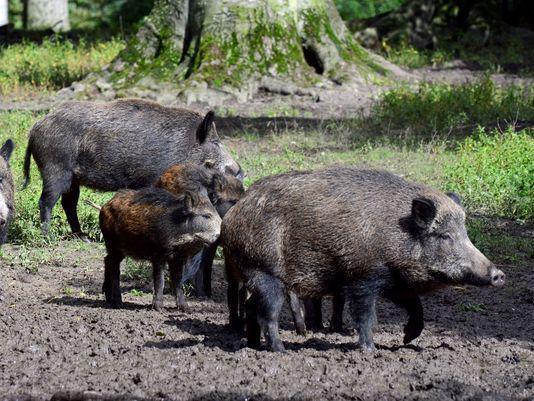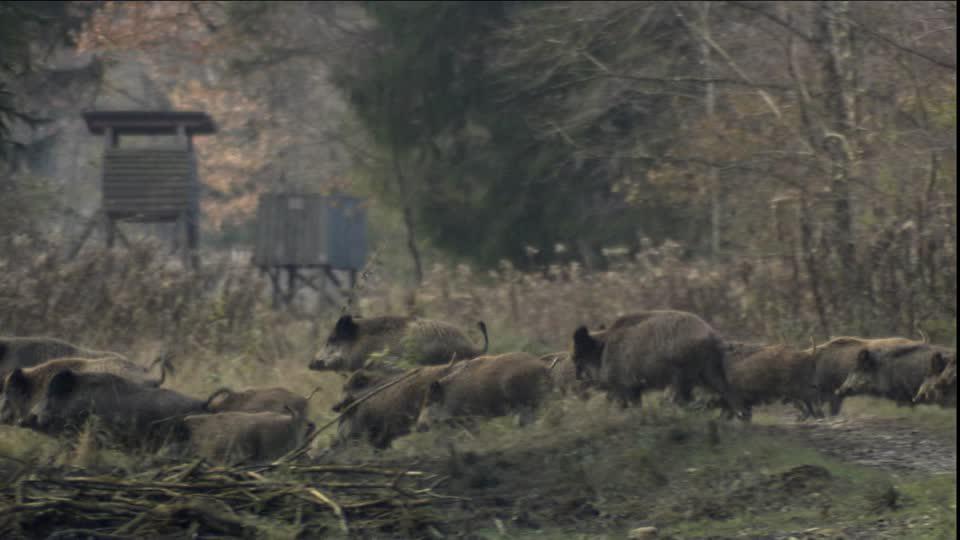The first image is the image on the left, the second image is the image on the right. Considering the images on both sides, is "An image contains one wild pig in the foreground with its body turned forward, in an area with snow covering the ground." valid? Answer yes or no. No. The first image is the image on the left, the second image is the image on the right. Examine the images to the left and right. Is the description "Only one image has animals in the snow." accurate? Answer yes or no. No. 